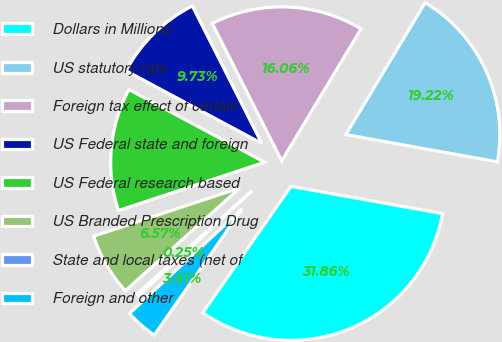<chart> <loc_0><loc_0><loc_500><loc_500><pie_chart><fcel>Dollars in Millions<fcel>US statutory rate<fcel>Foreign tax effect of certain<fcel>US Federal state and foreign<fcel>US Federal research based<fcel>US Branded Prescription Drug<fcel>State and local taxes (net of<fcel>Foreign and other<nl><fcel>31.86%<fcel>19.22%<fcel>16.06%<fcel>9.73%<fcel>12.9%<fcel>6.57%<fcel>0.25%<fcel>3.41%<nl></chart> 